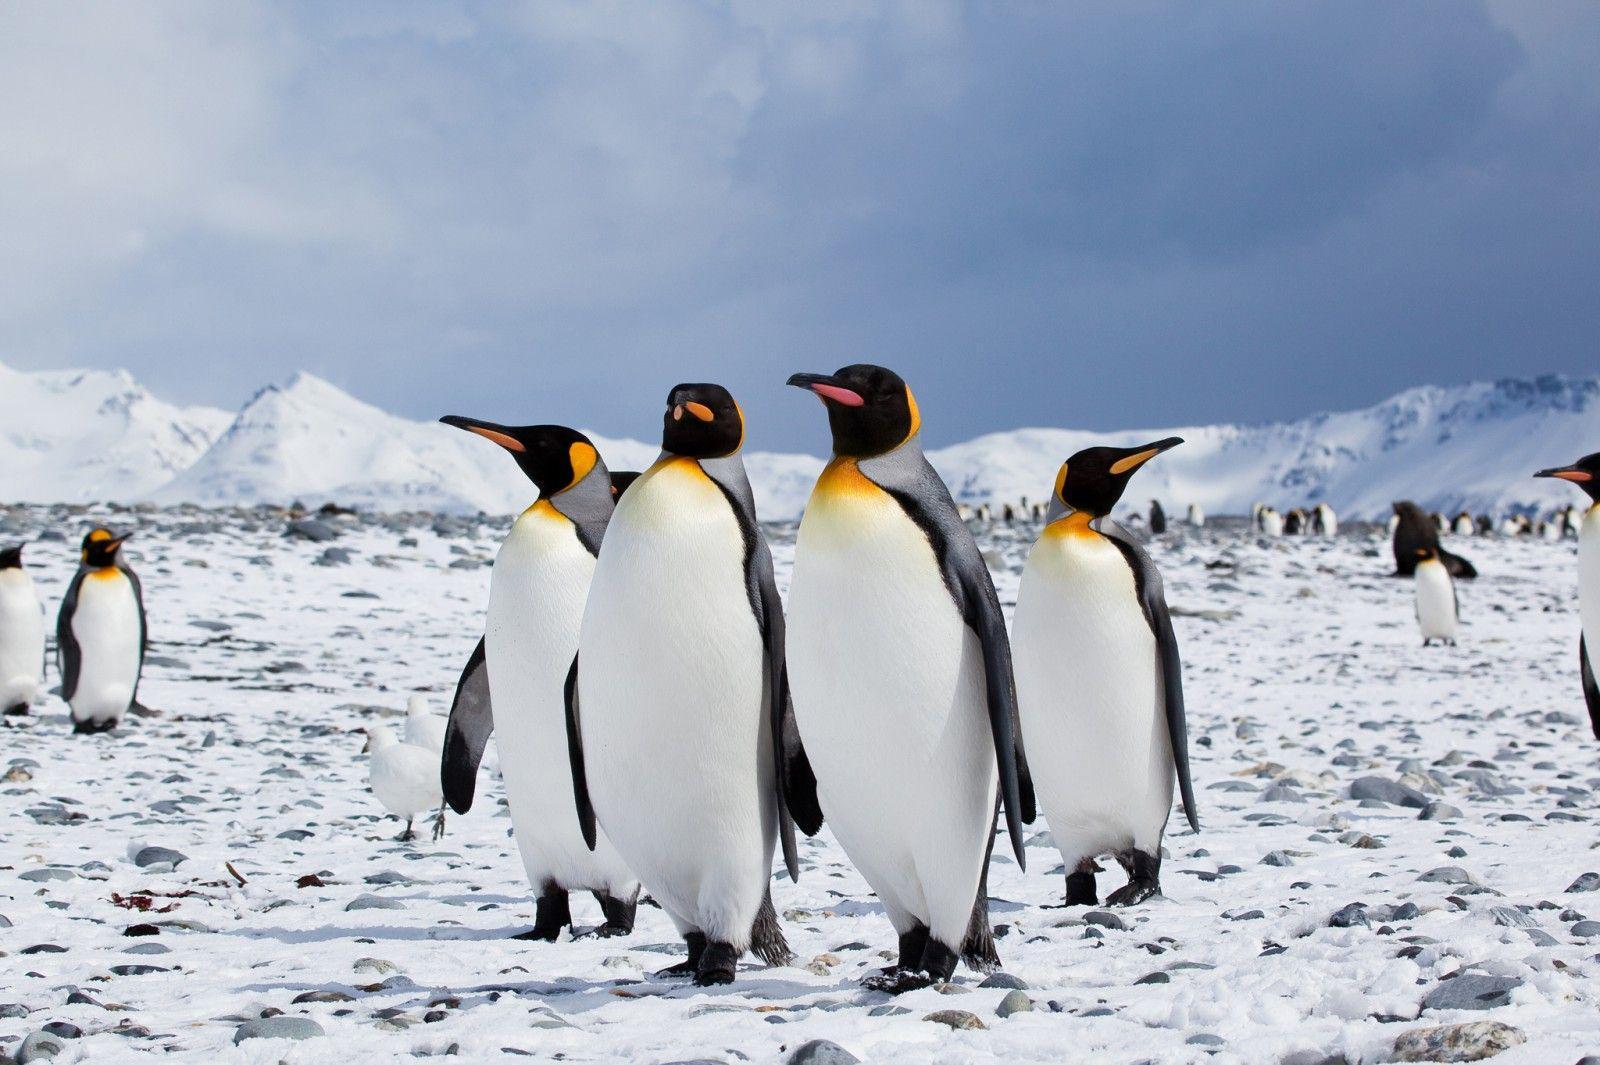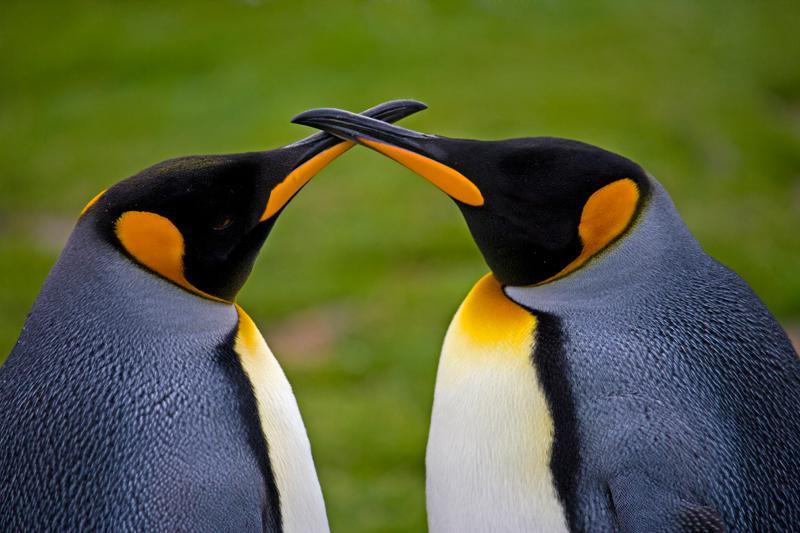The first image is the image on the left, the second image is the image on the right. Considering the images on both sides, is "At least one image has no more than two penguins." valid? Answer yes or no. Yes. 